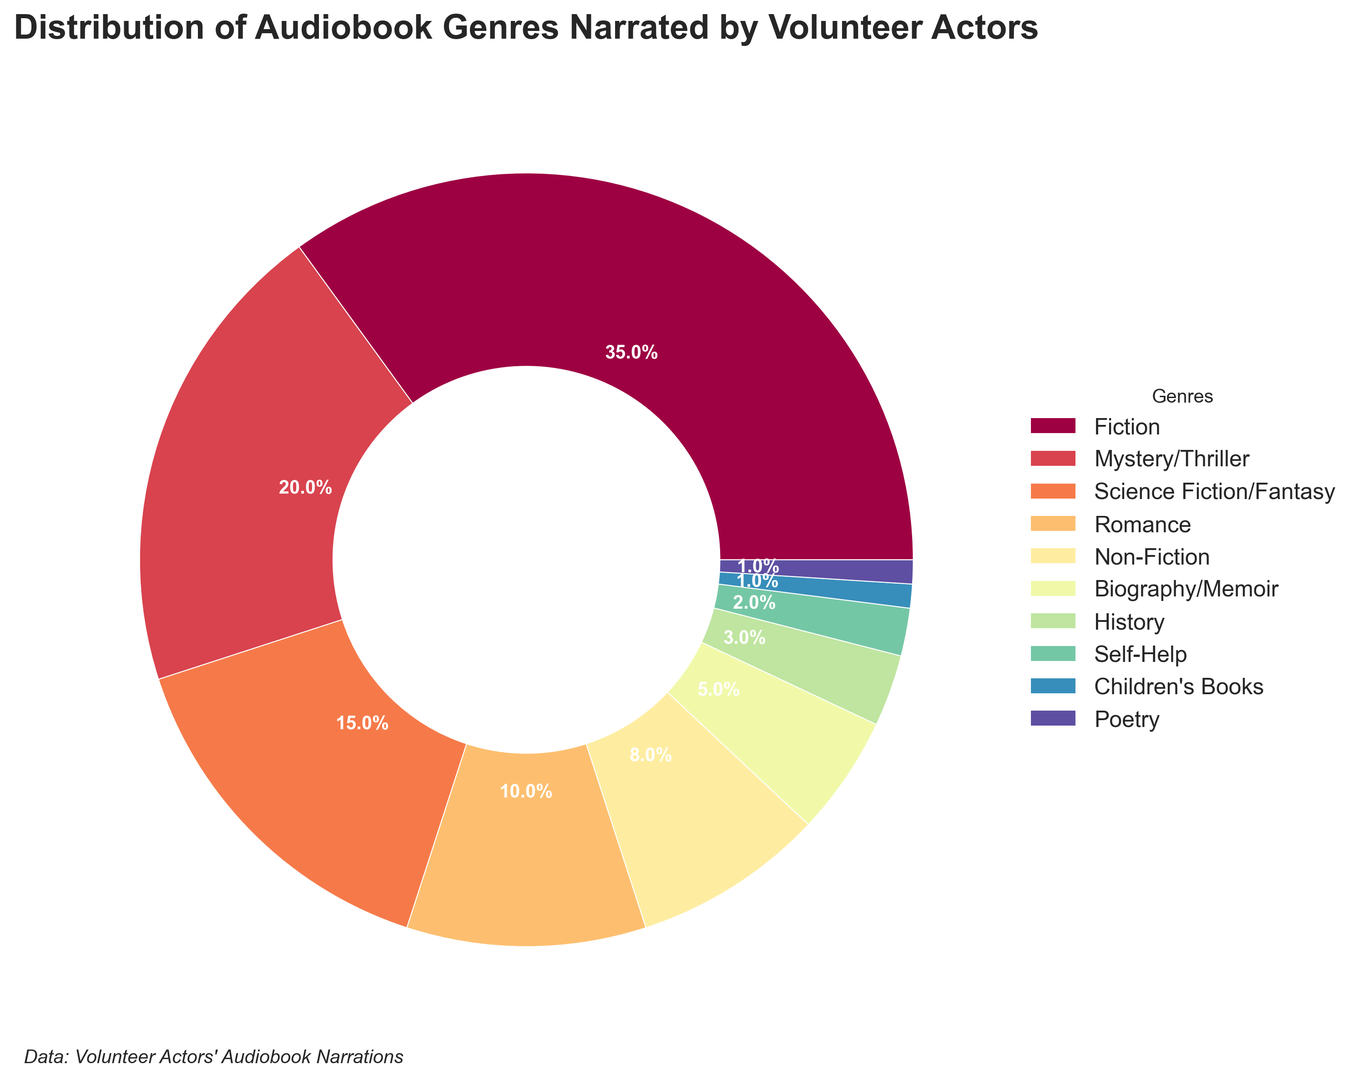Is Fiction the genre with the highest percentage? By looking at the chart, the Fiction genre occupies the largest section of the ring. Its percentage value reads 35%, which is higher than any other genre on the chart.
Answer: Yes What is the combined percentage of Mystery/Thriller and Science Fiction/Fantasy genres? The percentage for Mystery/Thriller is 20% and for Science Fiction/Fantasy is 15%. Adding these two percentages: 20% + 15% = 35%.
Answer: 35% Which genre has a smaller percentage, History or Biography/Memoir? By examining the sizes of the segments in the ring, the History genre occupies a smaller section compared to the Biography/Memoir genre. History has a 3% share while Biography/Memoir has a 5% share.
Answer: History What is the difference in percentage between Fiction and Non-Fiction genres? Fiction has a percentage of 35% and Non-Fiction has 8%. The difference between these two percentages is 35% - 8% = 27%.
Answer: 27% How many genres have a percentage smaller than 7%? By checking each genre on the ring chart, we see that Biography/Memoir (5%), History (3%), Self-Help (2%), Children's Books (1%), and Poetry (1%) all have percentages smaller than 7%. This totals five genres.
Answer: 5 Which genre occupies the segment with a dark blue color? The dark blue color corresponds to the Romance genre, as indicated in the legend beside the chart.
Answer: Romance If Fiction were to be split into two equal parts, what percentage would each part have? Fiction constitutes 35%. If divided equally into two parts: 35% / 2 = 17.5%. Each part would have 17.5%.
Answer: 17.5% Which genre has the closest percentage to the average of all genres? First, calculate the average percentage: (35 + 20 + 15 + 10 + 8 + 5 + 3 + 2 + 1 + 1) / 10 = 10%. Romance, at 10%, matches the average.
Answer: Romance Does the percentage of Romance narrations exceed the sum of History, Self-Help, Children's Books, and Poetry narrations? The total percentage of History, Self-Help, Children's Books, and Poetry is 3% + 2% + 1% + 1% = 7%. Romance, at 10%, indeed exceeds this total.
Answer: Yes What is the visual difference in segment size between Science Fiction/Fantasy and Non-Fiction? Science Fiction/Fantasy, at 15%, has a noticeably larger segment than Non-Fiction which is at 8%.
Answer: Science Fiction/Fantasy is larger 